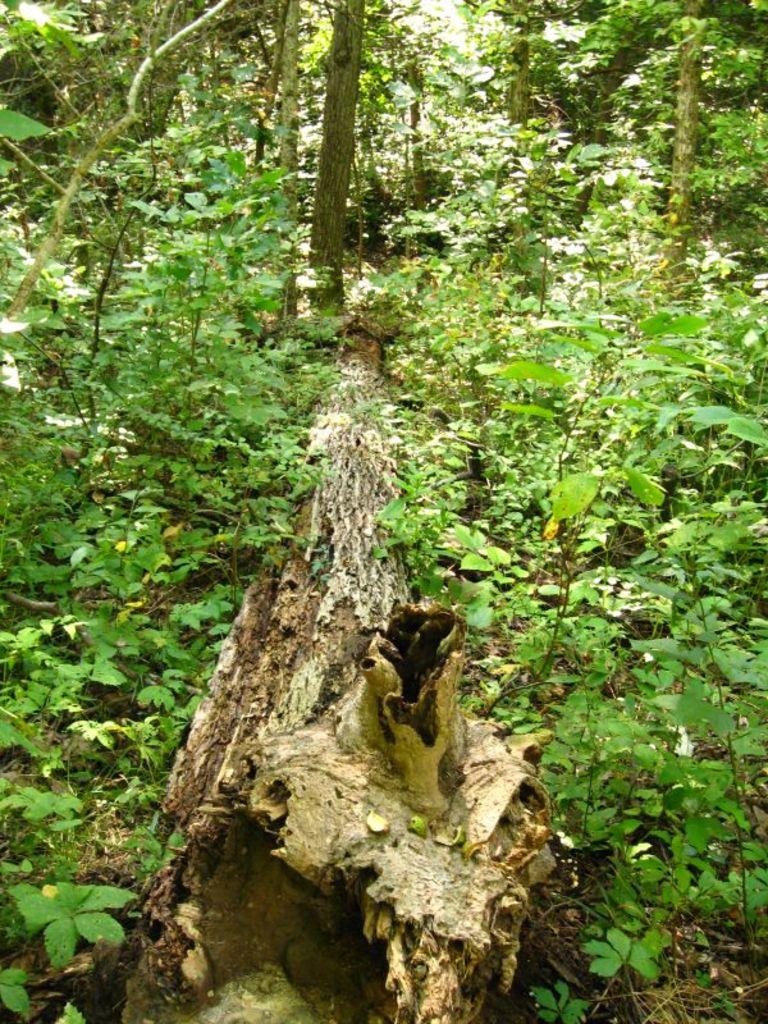What is the main object in the middle of the image? There is a log in the middle of the image. What type of natural environment is depicted in the image? The image features trees, which suggests a forest or wooded area. What color are the trees in the image? The trees are green in color. Can you see any chickens walking on the log in the image? There are no chickens present in the image, and therefore no such activity can be observed. 